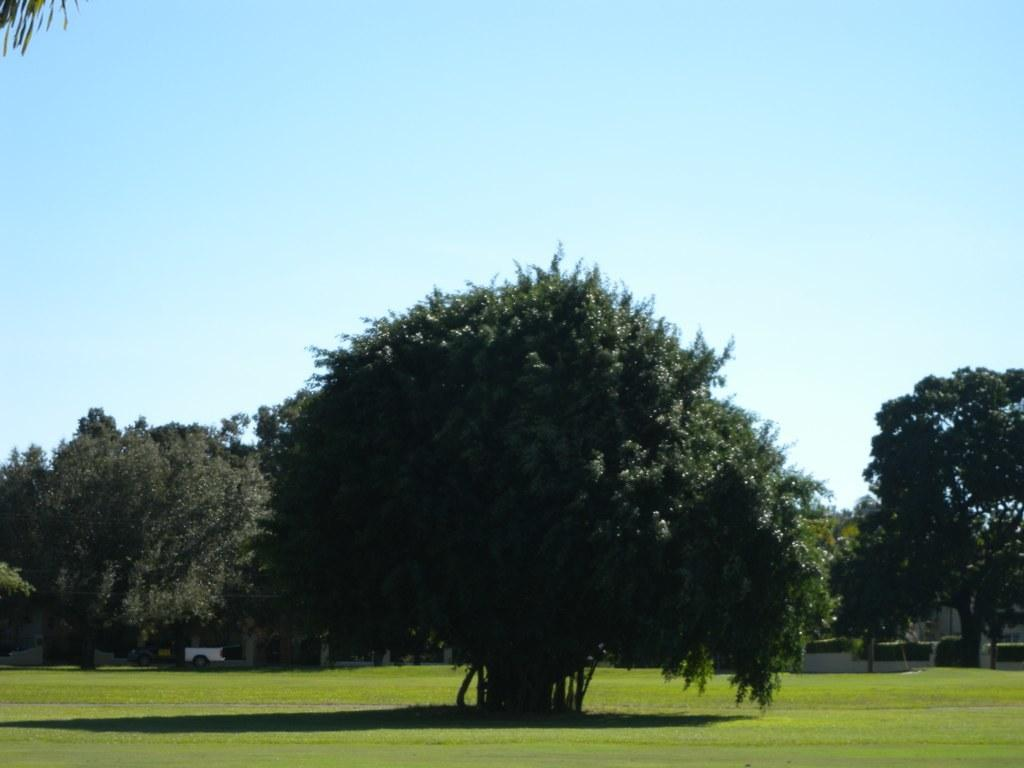What type of vegetation can be seen in the image? There are trees with branches and leaves in the image. What else can be seen on the ground in the image? There is grass in the image. What is visible in the background of the image? In the background, there appears to be a parked vehicle. Where can the lumber be found in the image? There is no lumber present in the image. What type of bushes are growing near the trees in the image? The provided facts do not mention any bushes; only trees with branches and leaves are mentioned. 